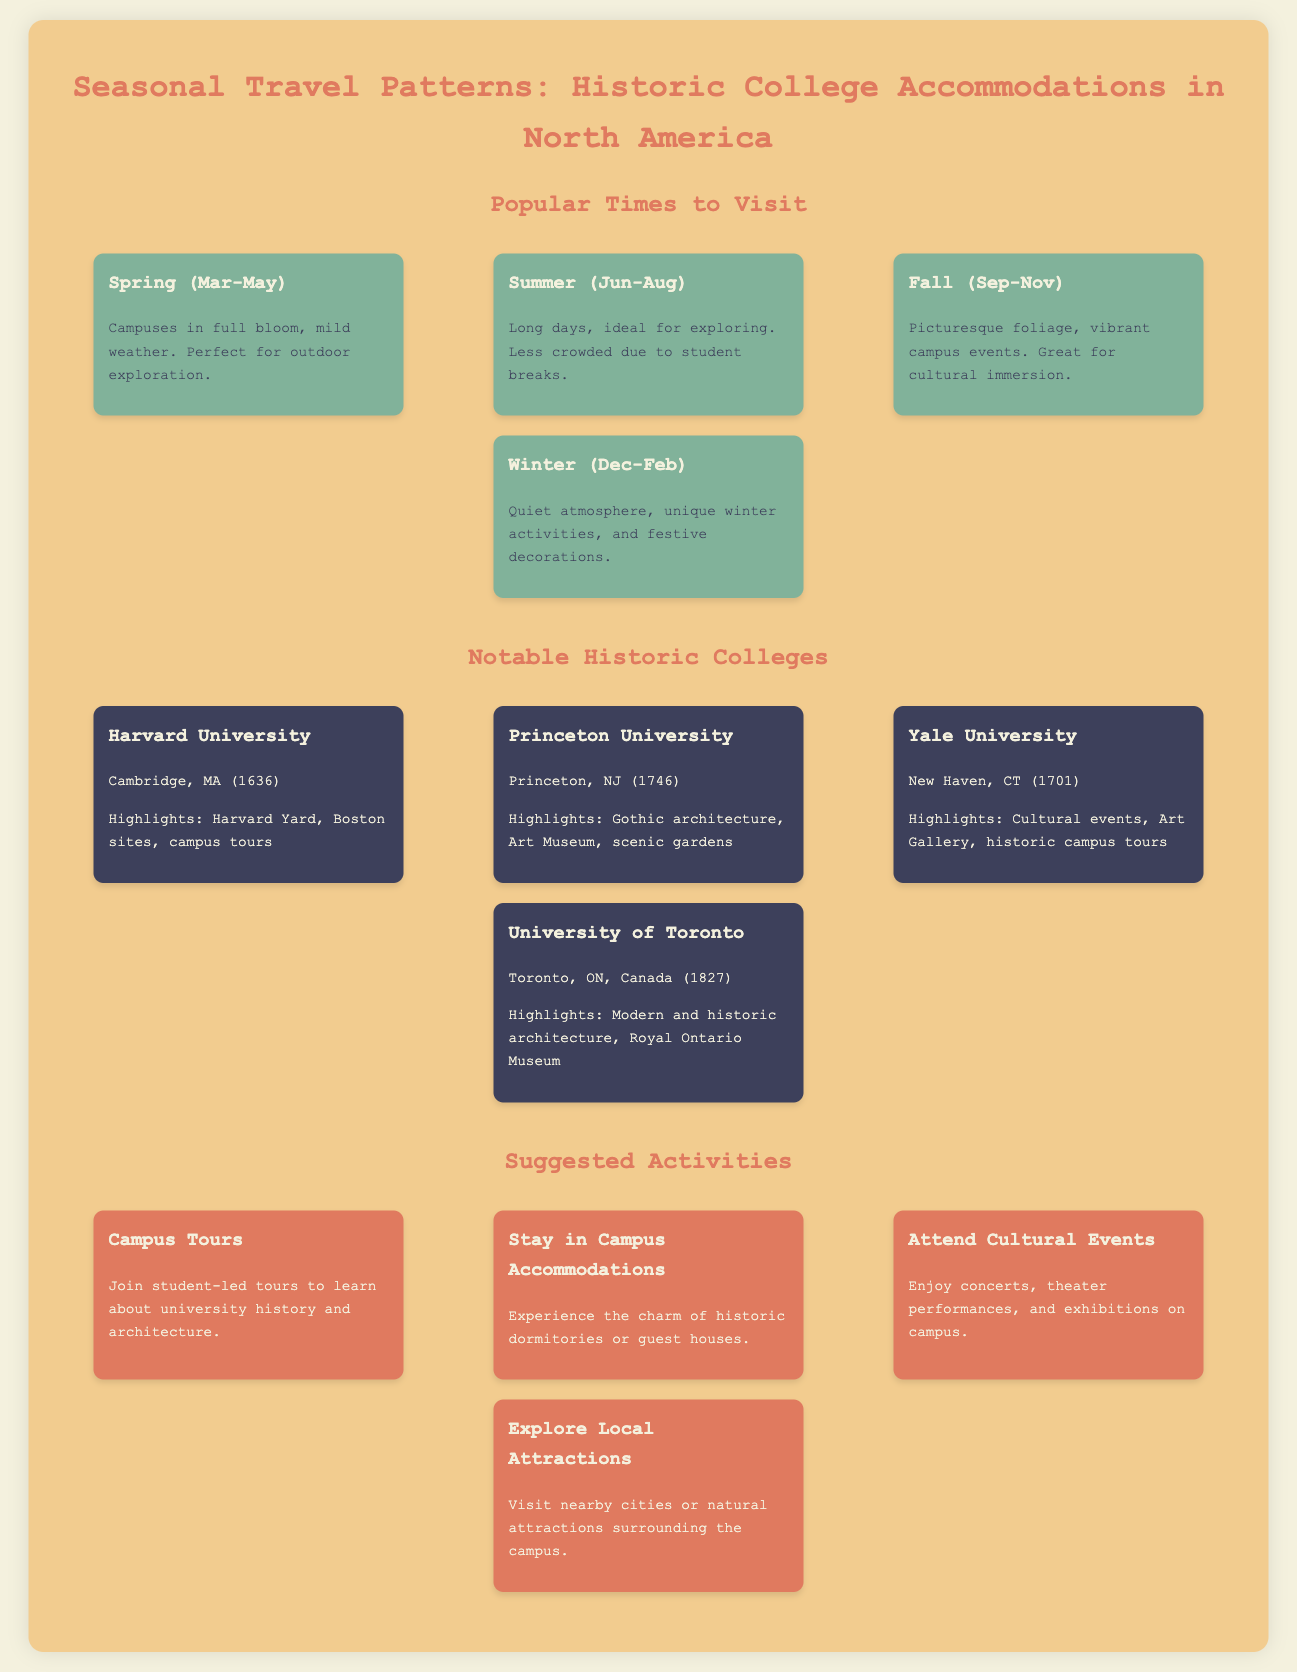What is the first month of spring? Spring is defined as March to May, thus the first month is March.
Answer: March Which college was established in 1636? Harvard University is noted as having been established in 1636.
Answer: Harvard University What activity involves student-led tours? The document mentions "Campus Tours" as the activity led by students.
Answer: Campus Tours What is a highlight of Yale University? A specific highlight of Yale University is its Art Gallery.
Answer: Art Gallery What season offers picturesque foliage? Fall, from September to November, is described as having picturesque foliage.
Answer: Fall Which college is located in Toronto, Canada? The University of Toronto is identified as being in Toronto, Ontario, Canada.
Answer: University of Toronto What season is ideal for exploring due to less crowded conditions? Summer is mentioned as less crowded because of student breaks.
Answer: Summer What are the months for winter? The winter season is indicated as December to February.
Answer: December to February 